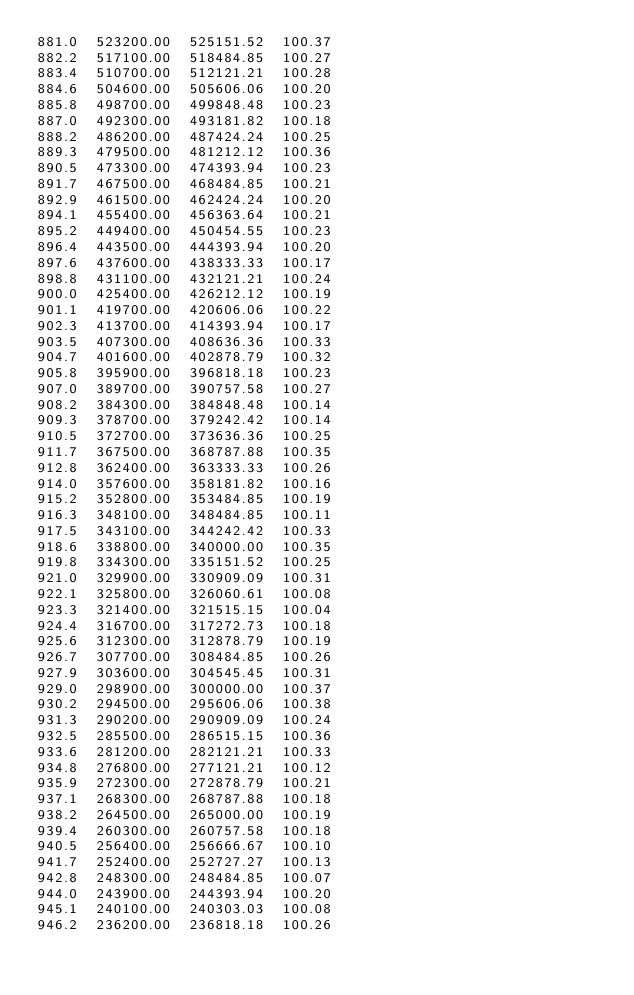Convert code to text. <code><loc_0><loc_0><loc_500><loc_500><_SML_>881.0  523200.00  525151.52  100.37
882.2  517100.00  518484.85  100.27
883.4  510700.00  512121.21  100.28
884.6  504600.00  505606.06  100.20
885.8  498700.00  499848.48  100.23
887.0  492300.00  493181.82  100.18
888.2  486200.00  487424.24  100.25
889.3  479500.00  481212.12  100.36
890.5  473300.00  474393.94  100.23
891.7  467500.00  468484.85  100.21
892.9  461500.00  462424.24  100.20
894.1  455400.00  456363.64  100.21
895.2  449400.00  450454.55  100.23
896.4  443500.00  444393.94  100.20
897.6  437600.00  438333.33  100.17
898.8  431100.00  432121.21  100.24
900.0  425400.00  426212.12  100.19
901.1  419700.00  420606.06  100.22
902.3  413700.00  414393.94  100.17
903.5  407300.00  408636.36  100.33
904.7  401600.00  402878.79  100.32
905.8  395900.00  396818.18  100.23
907.0  389700.00  390757.58  100.27
908.2  384300.00  384848.48  100.14
909.3  378700.00  379242.42  100.14
910.5  372700.00  373636.36  100.25
911.7  367500.00  368787.88  100.35
912.8  362400.00  363333.33  100.26
914.0  357600.00  358181.82  100.16
915.2  352800.00  353484.85  100.19
916.3  348100.00  348484.85  100.11
917.5  343100.00  344242.42  100.33
918.6  338800.00  340000.00  100.35
919.8  334300.00  335151.52  100.25
921.0  329900.00  330909.09  100.31
922.1  325800.00  326060.61  100.08
923.3  321400.00  321515.15  100.04
924.4  316700.00  317272.73  100.18
925.6  312300.00  312878.79  100.19
926.7  307700.00  308484.85  100.26
927.9  303600.00  304545.45  100.31
929.0  298900.00  300000.00  100.37
930.2  294500.00  295606.06  100.38
931.3  290200.00  290909.09  100.24
932.5  285500.00  286515.15  100.36
933.6  281200.00  282121.21  100.33
934.8  276800.00  277121.21  100.12
935.9  272300.00  272878.79  100.21
937.1  268300.00  268787.88  100.18
938.2  264500.00  265000.00  100.19
939.4  260300.00  260757.58  100.18
940.5  256400.00  256666.67  100.10
941.7  252400.00  252727.27  100.13
942.8  248300.00  248484.85  100.07
944.0  243900.00  244393.94  100.20
945.1  240100.00  240303.03  100.08
946.2  236200.00  236818.18  100.26</code> 